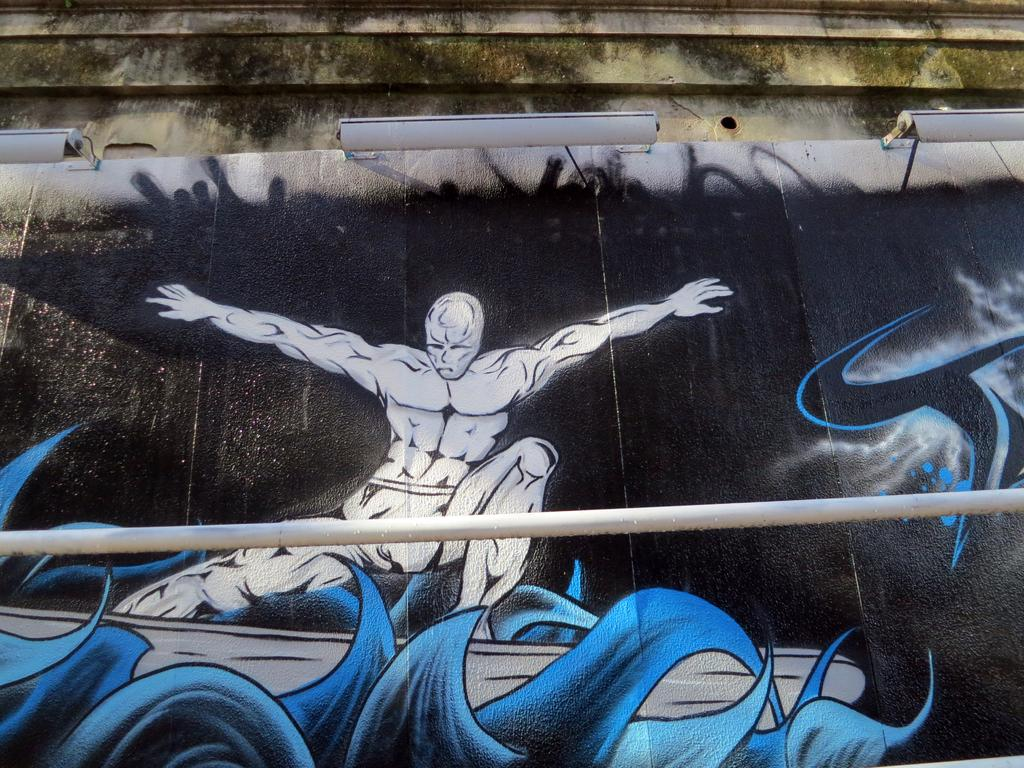What is depicted on the wall in the image? There is street art on a wall in the image. What type of lighting is present in the image? There are tube lights hanging on the wall. Can you describe an object in the foreground of the image? There is a rod in the foreground of the image. What type of twist can be seen in the cellar in the image? There is no cellar or twist present in the image; it features street art on a wall and tube lights hanging on the wall. 